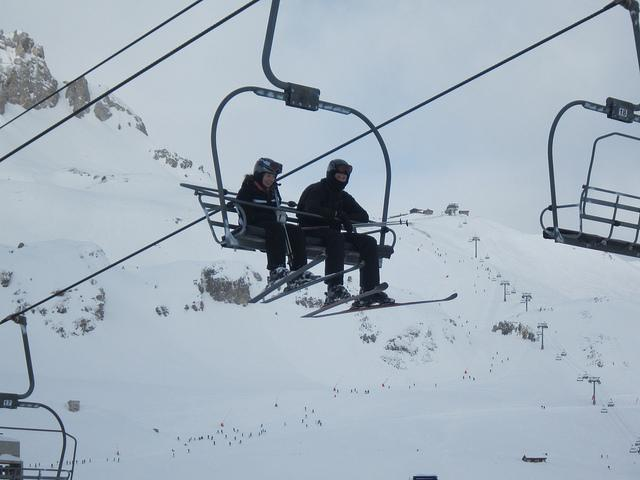The ski lift saves the skiers from a lot of what physical activity? climbing 